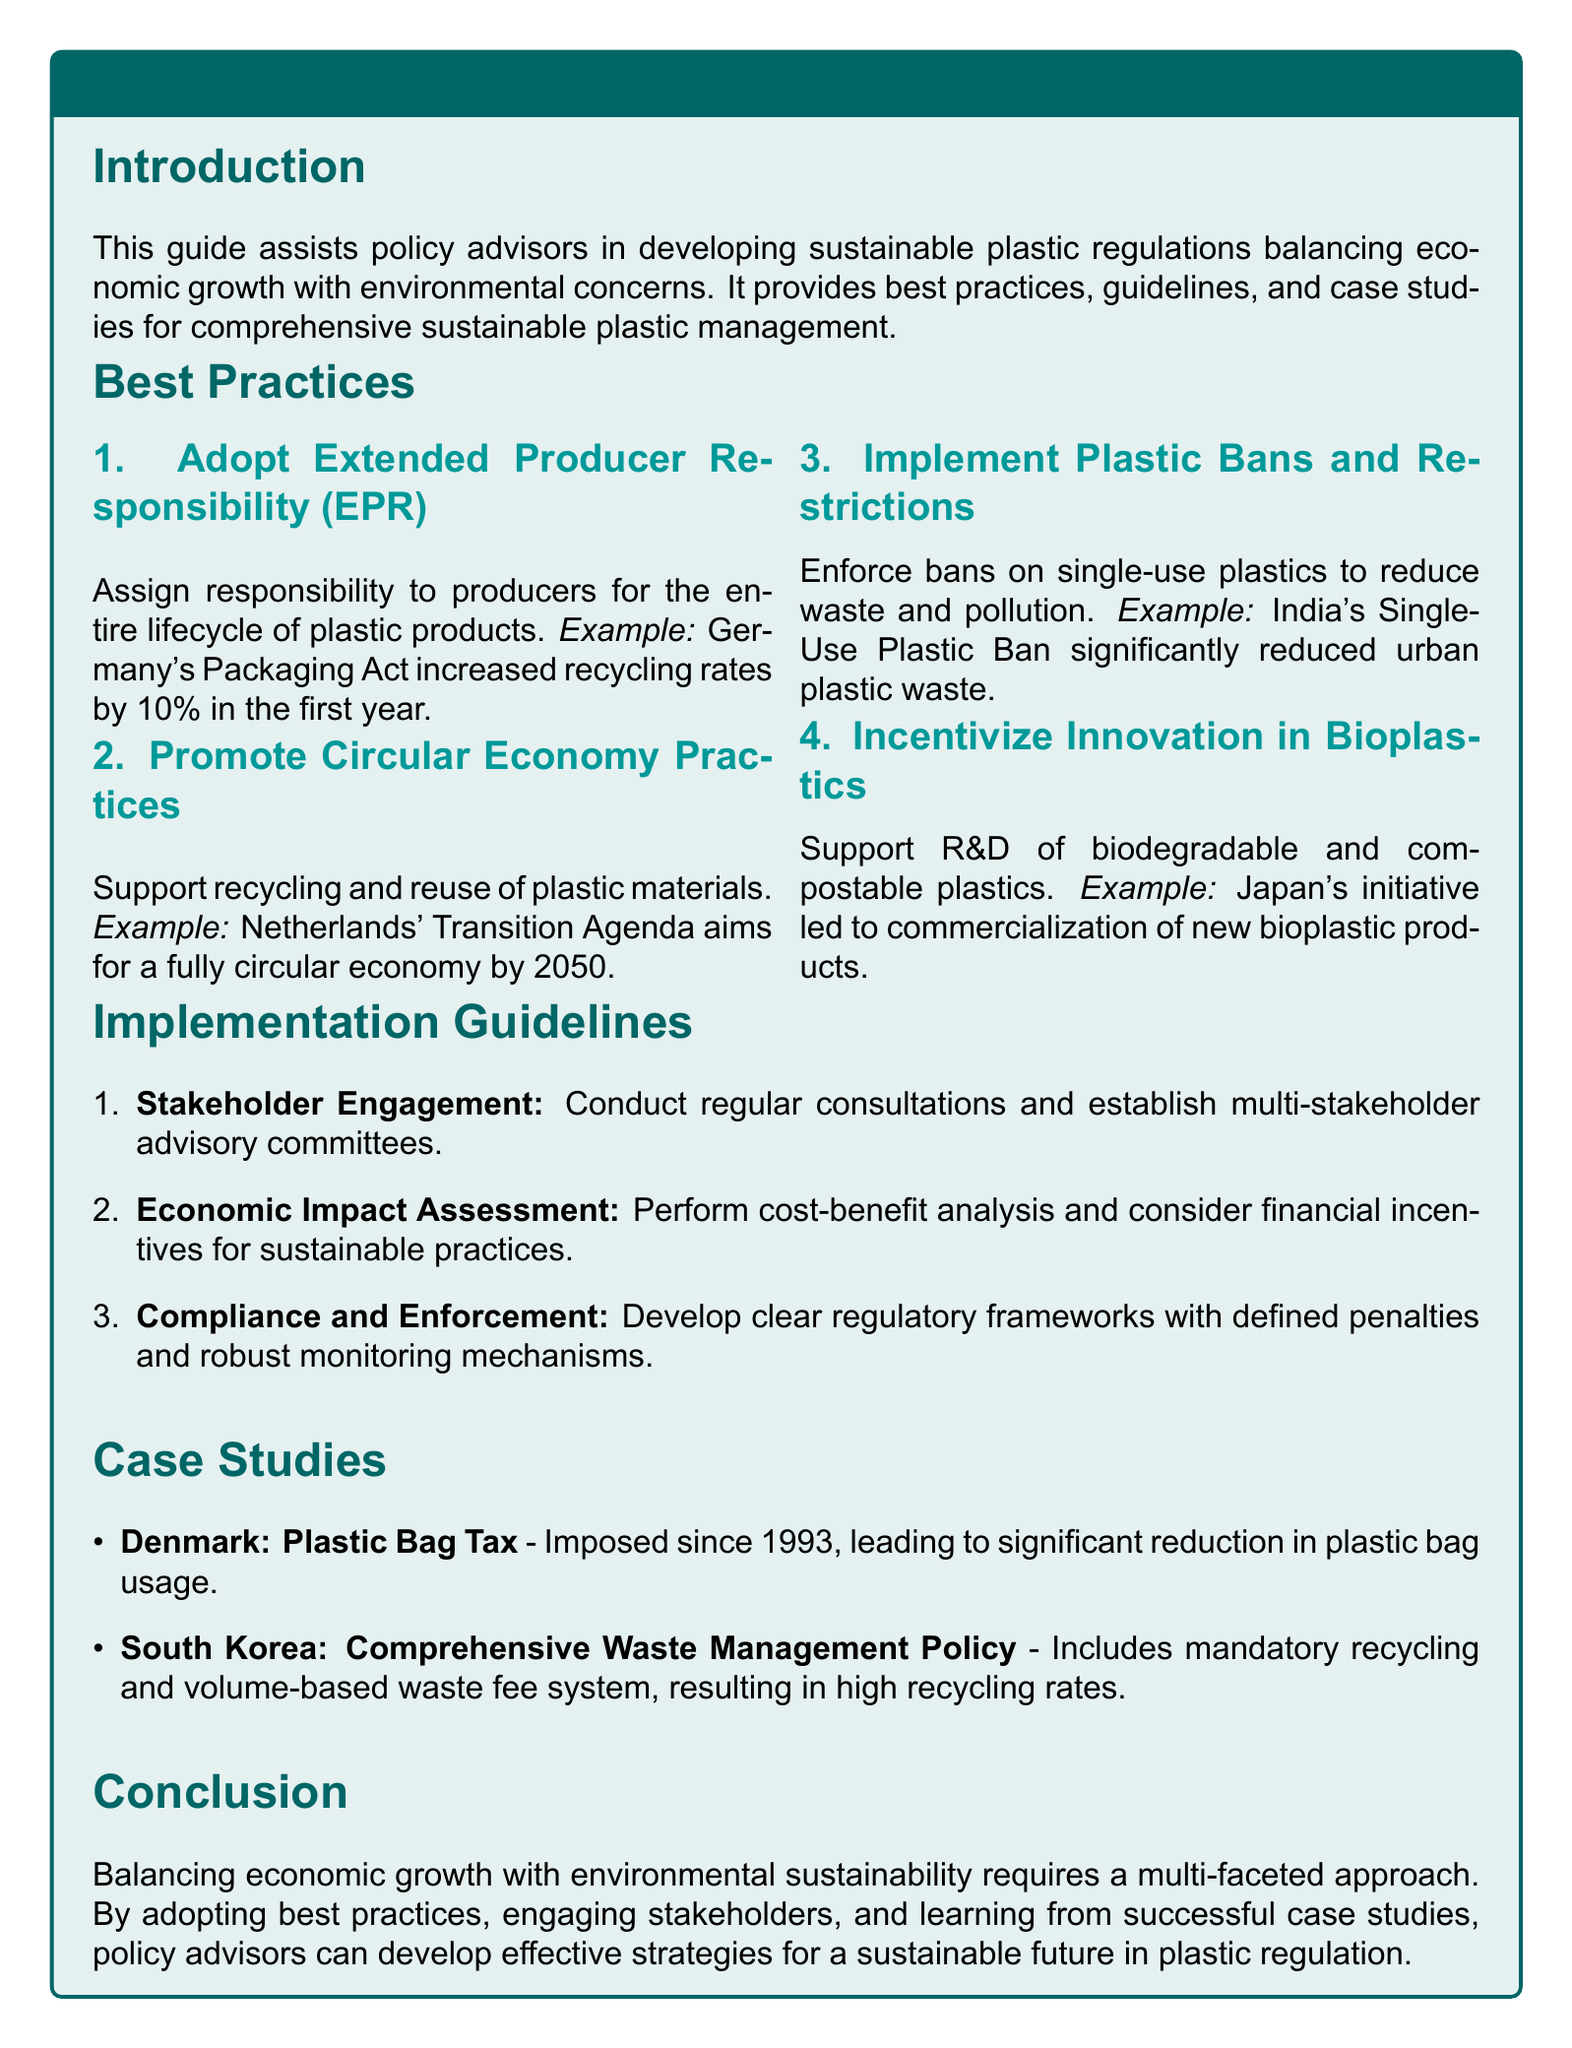What is the main purpose of the guide? The guide assists policy advisors in developing sustainable plastic regulations balancing economic growth with environmental concerns.
Answer: Assists policy advisors What is one example of Extended Producer Responsibility? The example provided in the guide highlights Germany's Packaging Act and its effects.
Answer: Germany's Packaging Act What year was Denmark's Plastic Bag Tax imposed? The guide states that this tax has been in place since 1993.
Answer: 1993 What percentage increase in recycling rates did Germany achieve in the first year of its Packaging Act? According to the document, the increase in recycling rates was 10 percent in the first year.
Answer: 10% What type of innovation does the guide incentivize in the plastic industry? The guide specifically mentions support for biodegradable and compostable plastics as an area for innovation.
Answer: Bioplastics How many implementation guidelines are listed in the document? By counting the enumerated items under Implementation Guidelines, it can be determined that there are three items listed.
Answer: 3 Which country's approach aims for a fully circular economy by 2050? The document highlights the Netherlands' Transition Agenda as an example of this goal.
Answer: Netherlands What is a significant effect of India's Single-Use Plastic Ban? The guide notes that it significantly reduced urban plastic waste.
Answer: Reduced urban plastic waste What is essential for maintaining stakeholder engagement according to the guide? The document emphasizes the importance of conducting regular consultations.
Answer: Regular consultations 